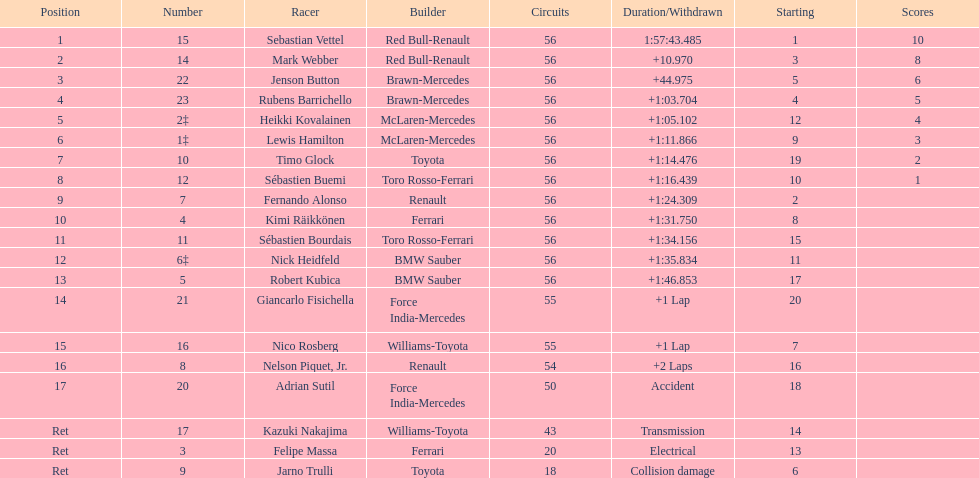What is the total number of drivers on the list? 20. 